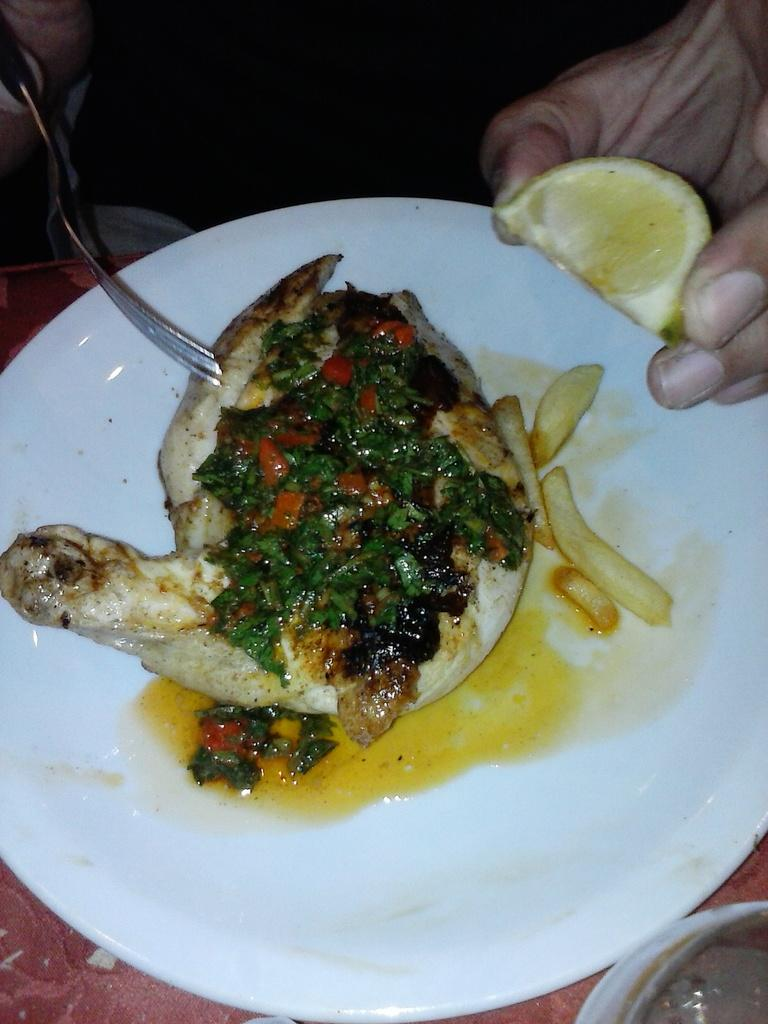What is on the plate that is visible in the image? There is a food item on the plate in the image. What utensil is visible in the image? A fork is visible in the image. What is the person's hand holding in the image? The person's hand is holding a piece of lemon in the image. What type of shoe is visible in the image? There is no shoe present in the image. Can you describe the person's mom in the image? There is no person's mom depicted in the image. 